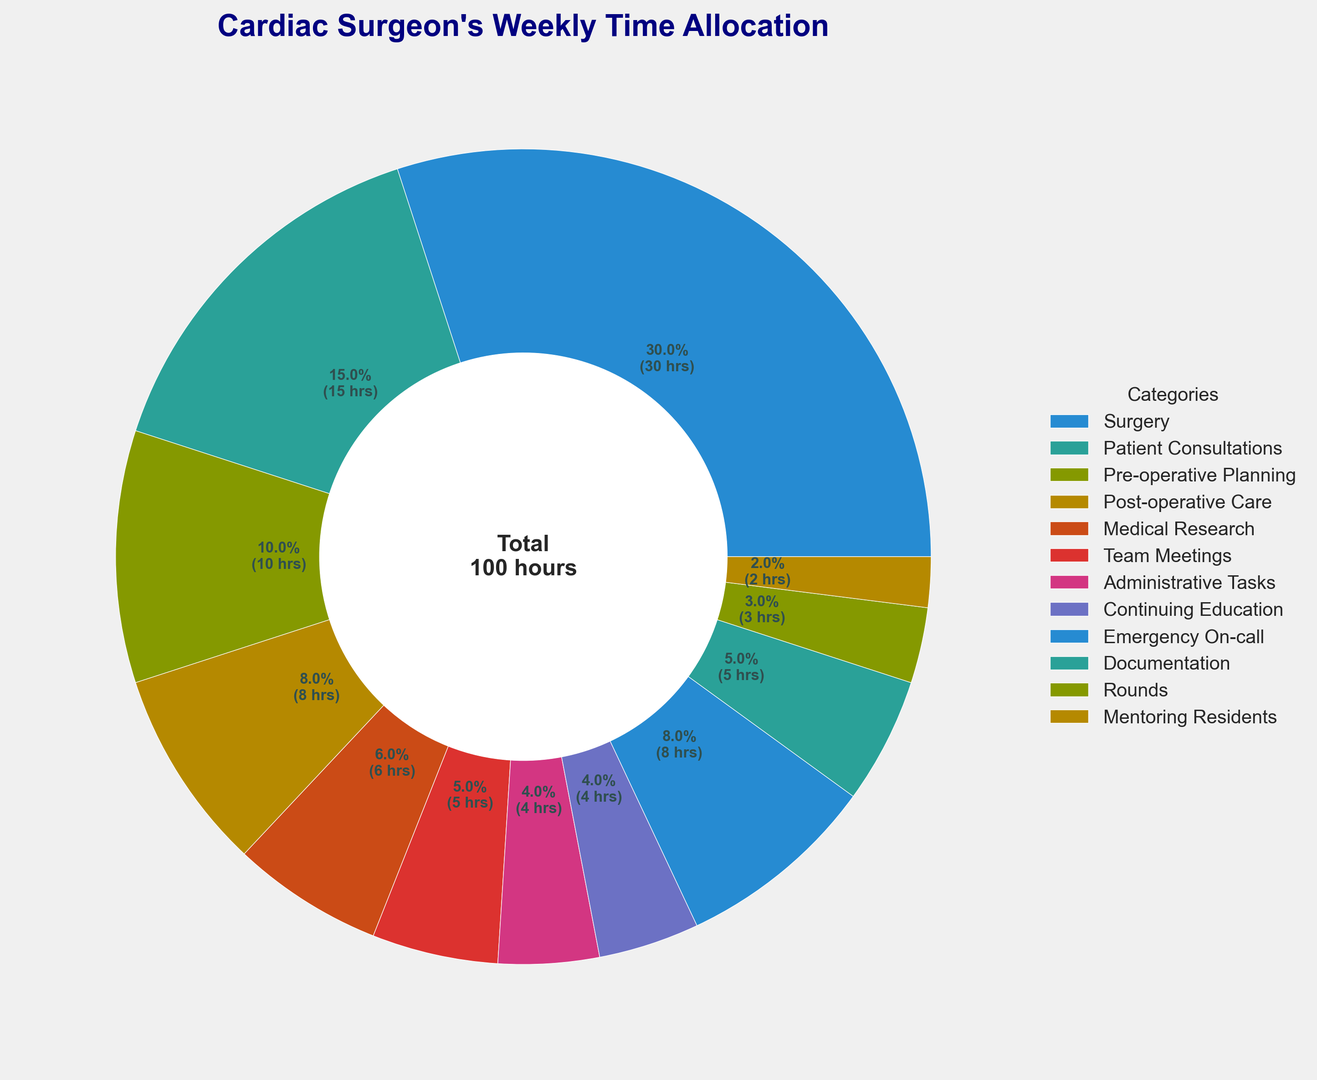What is the total number of hours spent on Surgery and Patient Consultations? Add the hours spent on Surgery (30) and Patient Consultations (15). 30 + 15 = 45 hours.
Answer: 45 hours Which activity takes more time, Pre-operative Planning or Post-operative Care? Compare the hours spent on Pre-operative Planning (10) to the hours spent on Post-operative Care (8). 10 is greater than 8.
Answer: Pre-operative Planning How many more hours does a cardiac surgeon spend on Medical Research compared to Mentoring Residents? Subtract the hours spent on Mentoring Residents (2) from the hours spent on Medical Research (6). 6 - 2 = 4 hours.
Answer: 4 hours What is the combined time allocation for Team Meetings, Administrative Tasks, and Documentation? Add the hours spent on Team Meetings (5), Administrative Tasks (4), and Documentation (5). 5 + 4 + 5 = 14 hours.
Answer: 14 hours Which activity has the smallest time allocation? Identify the activity with the smallest number of hours. Mentoring Residents has 2 hours, which is the smallest.
Answer: Mentoring Residents Compare the time spent on Continuing Education to Rounds. How much more or less is it? Subtract the hours spent on Rounds (3) from the hours spent on Continuing Education (4). 4 - 3 = 1 hour.
Answer: 1 hour more What percentage of the week does the surgeon spend on Emergency On-call? Find the proportion of Emergency On-call hours (8) relative to the total hours (90) and convert it to a percentage. (8/90) * 100 ≈ 8.9%.
Answer: About 8.9% How many hours does the surgeon spend on tasks that are related to direct patient interactions (Surgery, Patient Consultations, Post-operative Care, and Rounds)? Add the hours spent on Surgery (30), Patient Consultations (15), Post-operative Care (8), and Rounds (3). 30 + 15 + 8 + 3 = 56 hours.
Answer: 56 hours 